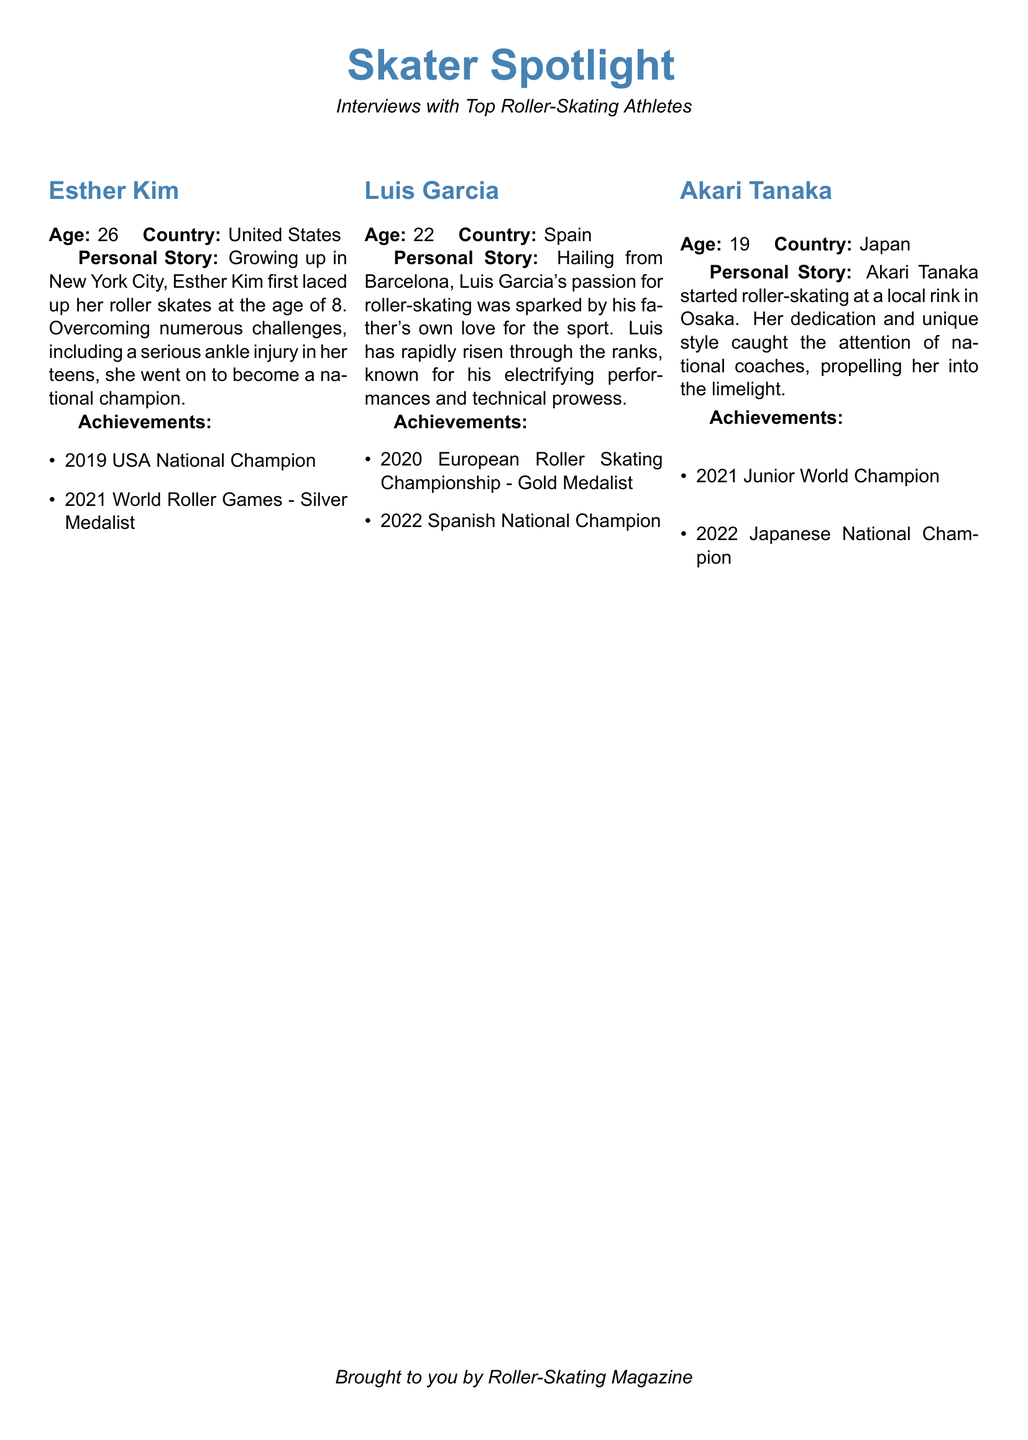What is Esther Kim's age? Esther Kim's age is provided in the personal information section.
Answer: 26 What country is Luis Garcia from? The country of Luis Garcia is mentioned alongside his personal details.
Answer: Spain How many medals did Esther Kim achieve in the World Roller Games? The document lists Esther Kim's achievements, including her medal in the World Roller Games.
Answer: Silver Medal Which city did Akari Tanaka start roller-skating in? The personal story of Akari Tanaka mentions the city where she began skating.
Answer: Osaka What year did Luis Garcia become the Spanish National Champion? The document specifies the year Luis Garcia achieved the Spanish National Championship title.
Answer: 2022 Who is the 2021 Junior World Champion? Akari Tanaka's achievements include her title as Junior World Champion.
Answer: Akari Tanaka Which skater overcame a serious ankle injury? The personal story of Esther Kim discusses the challenges she overcame, including an ankle injury.
Answer: Esther Kim What is the title of this segment in the magazine? The title of the segment is prominently featured at the beginning of the document.
Answer: Skater Spotlight 